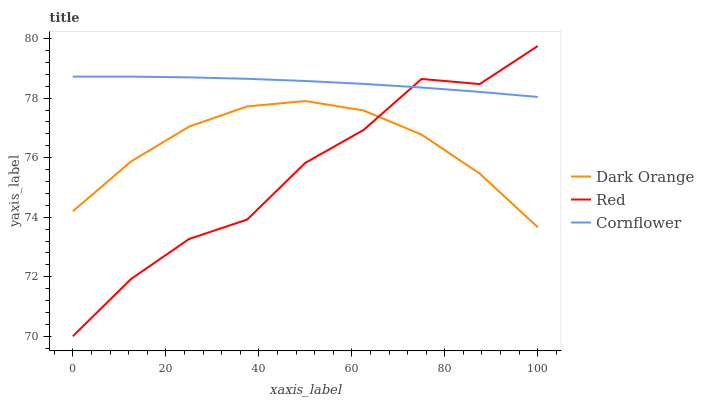Does Cornflower have the minimum area under the curve?
Answer yes or no. No. Does Red have the maximum area under the curve?
Answer yes or no. No. Is Red the smoothest?
Answer yes or no. No. Is Cornflower the roughest?
Answer yes or no. No. Does Cornflower have the lowest value?
Answer yes or no. No. Does Cornflower have the highest value?
Answer yes or no. No. Is Dark Orange less than Cornflower?
Answer yes or no. Yes. Is Cornflower greater than Dark Orange?
Answer yes or no. Yes. Does Dark Orange intersect Cornflower?
Answer yes or no. No. 